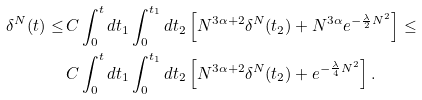<formula> <loc_0><loc_0><loc_500><loc_500>\delta ^ { N } ( t ) \leq \, & C \int _ { 0 } ^ { t } d t _ { 1 } \int _ { 0 } ^ { t _ { 1 } } d t _ { 2 } \left [ N ^ { 3 \alpha + 2 } \delta ^ { N } ( t _ { 2 } ) + N ^ { 3 \alpha } e ^ { - \frac { \lambda } { 2 } N ^ { 2 } } \right ] \leq \\ & C \int _ { 0 } ^ { t } d t _ { 1 } \int _ { 0 } ^ { t _ { 1 } } d t _ { 2 } \left [ N ^ { 3 \alpha + 2 } \delta ^ { N } ( t _ { 2 } ) + e ^ { - \frac { \lambda } { 4 } N ^ { 2 } } \right ] .</formula> 